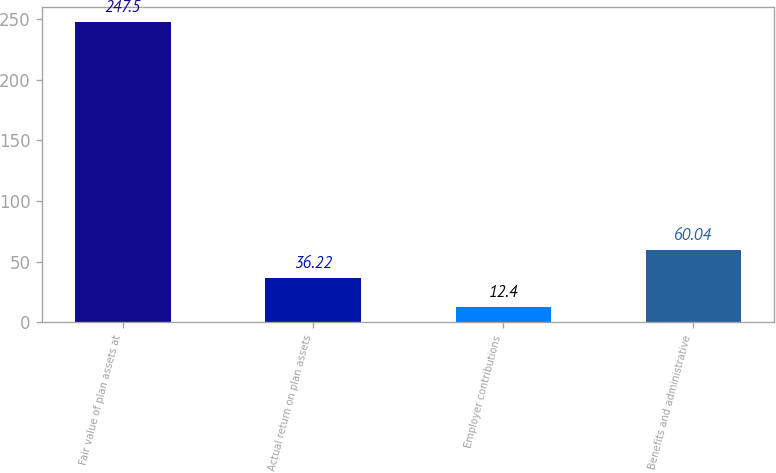Convert chart. <chart><loc_0><loc_0><loc_500><loc_500><bar_chart><fcel>Fair value of plan assets at<fcel>Actual return on plan assets<fcel>Employer contributions<fcel>Benefits and administrative<nl><fcel>247.5<fcel>36.22<fcel>12.4<fcel>60.04<nl></chart> 